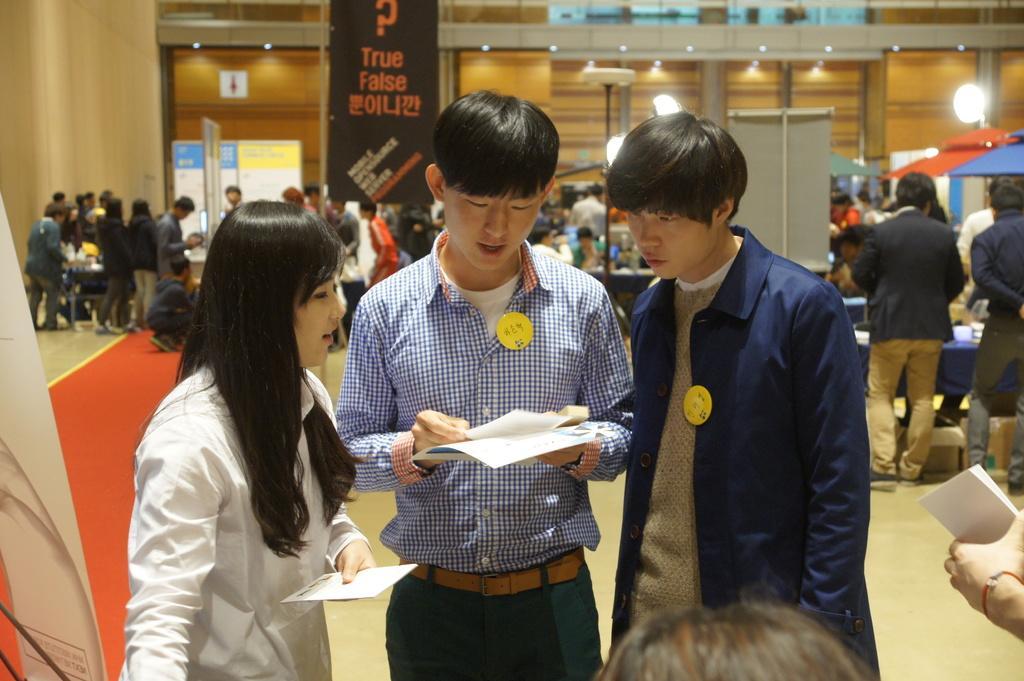In one or two sentences, can you explain what this image depicts? In this image we can see three people standing on the floor and holding some papers in their hands. In front of them there is a head of a person. In the back of them there are so many people standing, in front of them there is a table. In the background there is a wall and lights. 